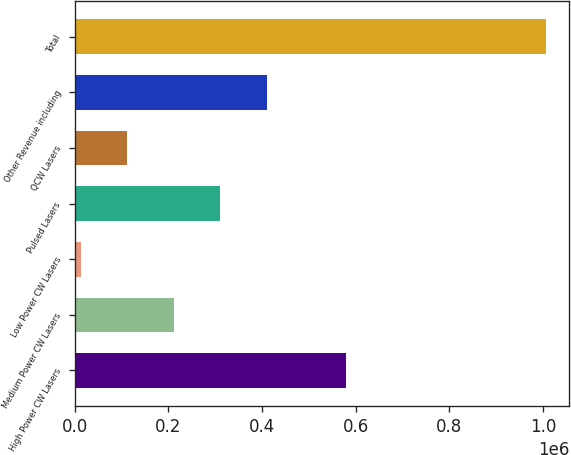Convert chart. <chart><loc_0><loc_0><loc_500><loc_500><bar_chart><fcel>High Power CW Lasers<fcel>Medium Power CW Lasers<fcel>Low Power CW Lasers<fcel>Pulsed Lasers<fcel>QCW Lasers<fcel>Other Revenue including<fcel>Total<nl><fcel>578668<fcel>211465<fcel>12788<fcel>310804<fcel>112126<fcel>410142<fcel>1.00617e+06<nl></chart> 